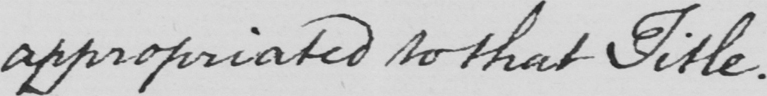Please transcribe the handwritten text in this image. appropriated to that title . 